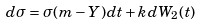<formula> <loc_0><loc_0><loc_500><loc_500>d \sigma = \sigma ( m - Y ) d t + k d W _ { 2 } ( t )</formula> 